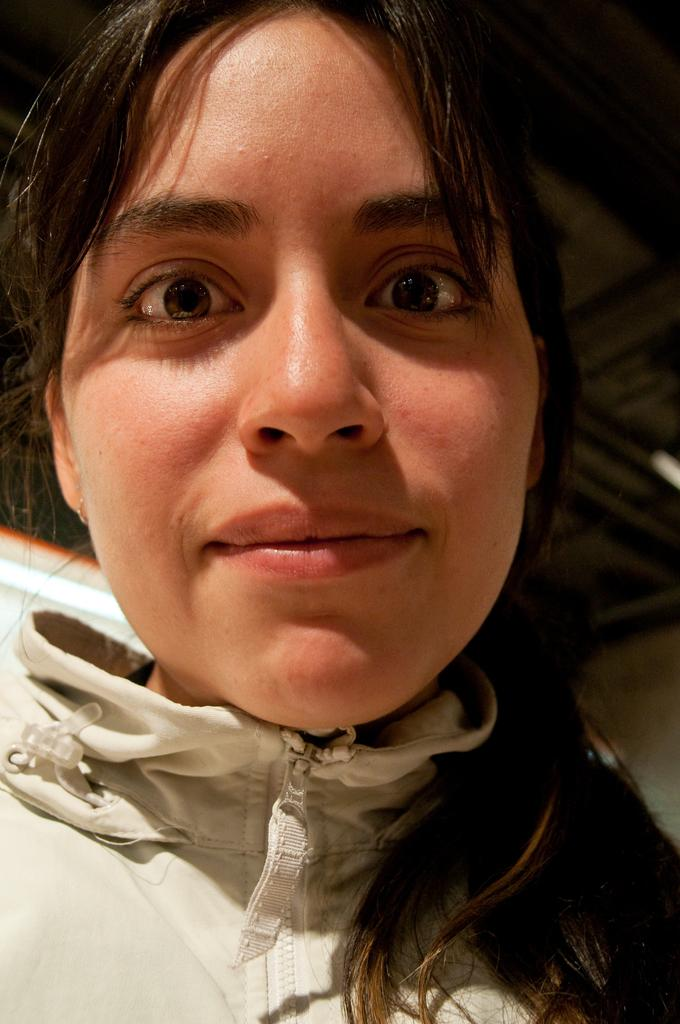What is the main subject of the image? The main subject of the image is a woman's face. What expression does the woman have in the image? The woman is smiling in the image. How many rabbits can be seen playing in the woman's pocket in the image? There are no rabbits or pockets visible in the image; it only features a woman's face. 